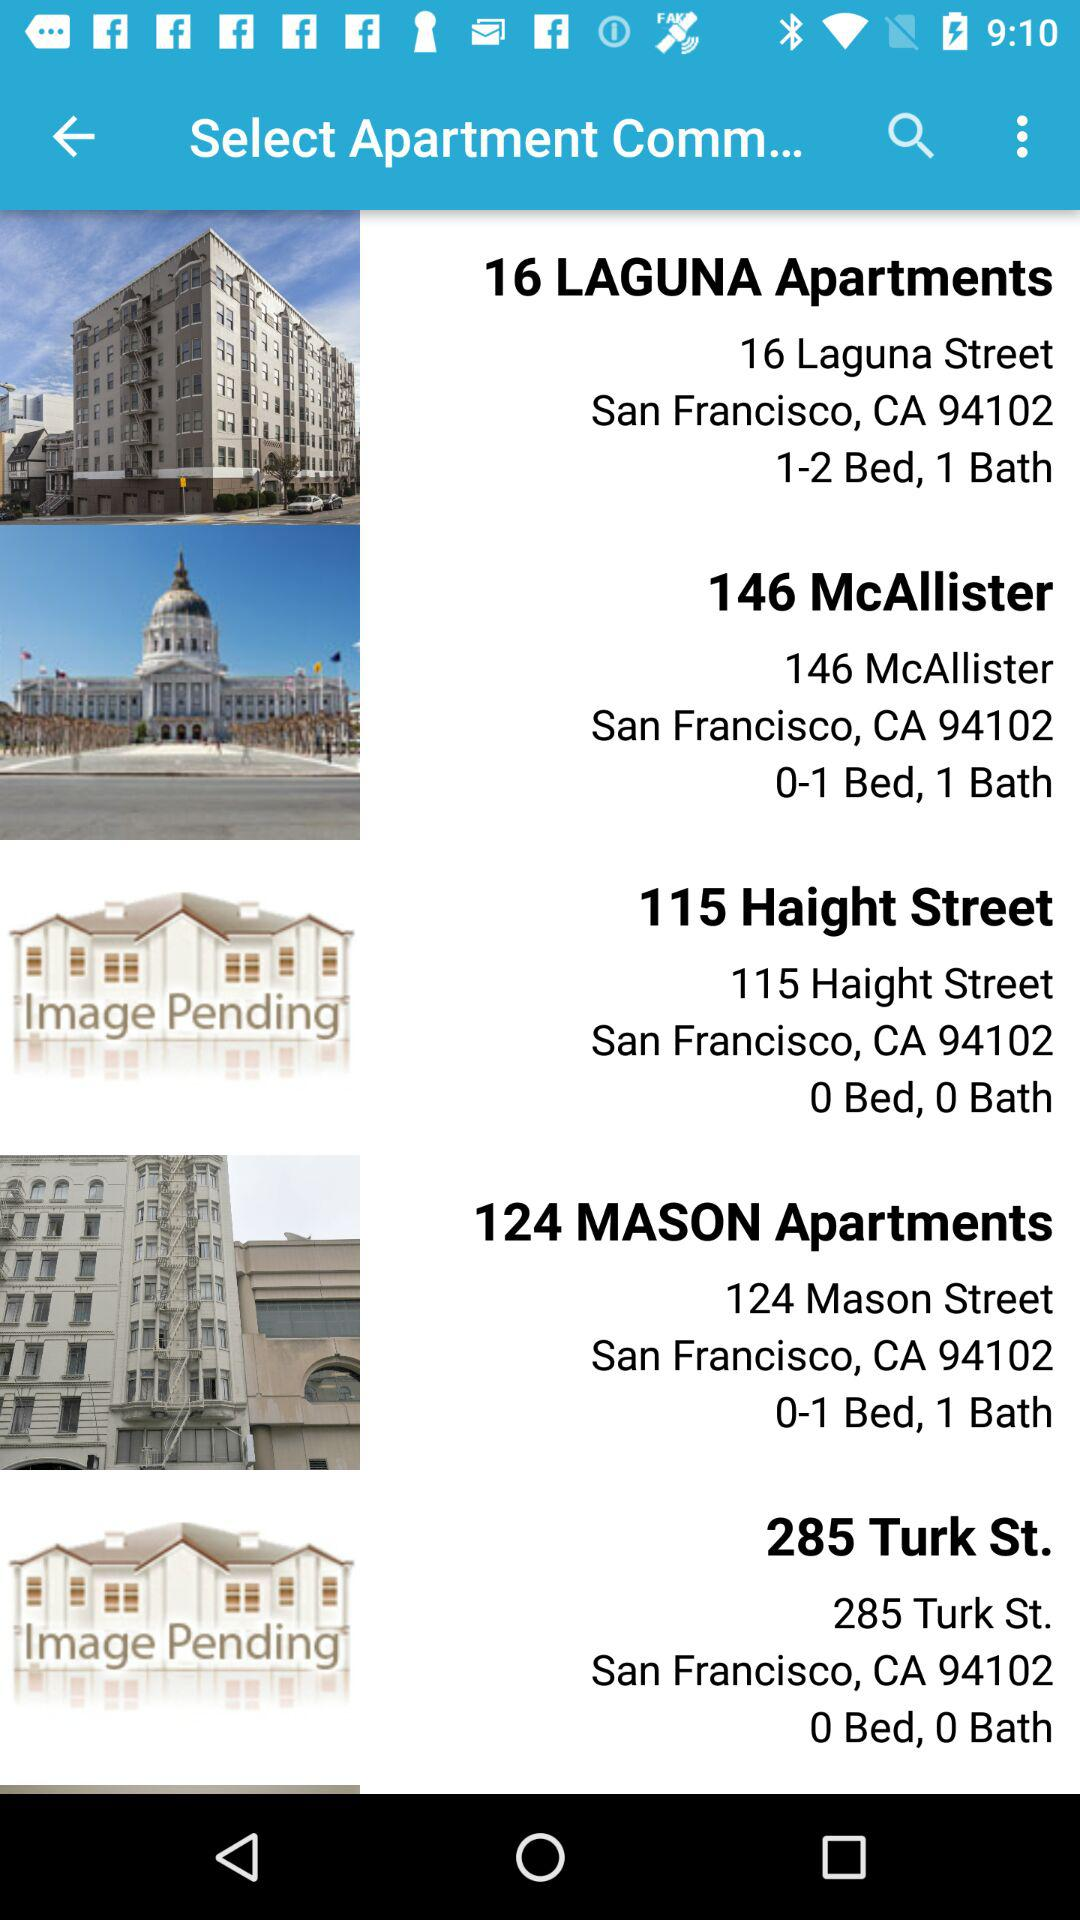How many beds and baths are there in the 115 Haight Street apartment? There are 0 beds and 0 baths. 